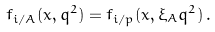<formula> <loc_0><loc_0><loc_500><loc_500>f _ { i / A } ( x , q ^ { 2 } ) = f _ { i / p } ( x , \xi _ { A } q ^ { 2 } ) \, .</formula> 